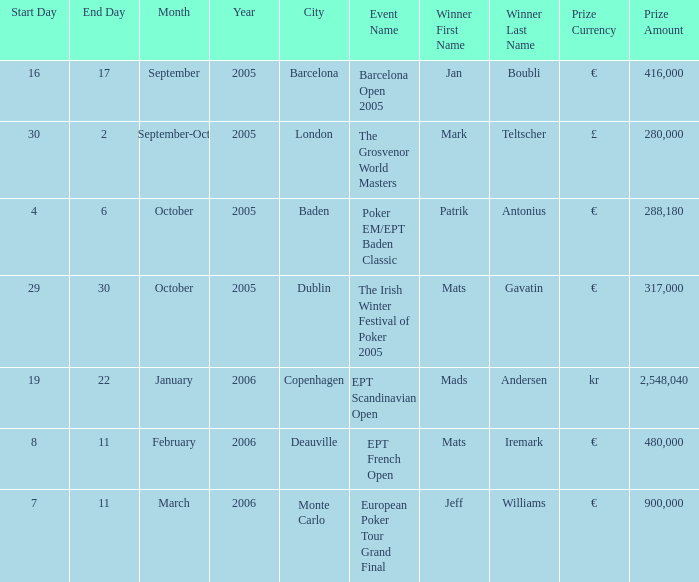Parse the table in full. {'header': ['Start Day', 'End Day', 'Month', 'Year', 'City', 'Event Name', 'Winner First Name', 'Winner Last Name', 'Prize Currency', 'Prize Amount'], 'rows': [['16', '17', 'September', '2005', 'Barcelona', 'Barcelona Open 2005', 'Jan', 'Boubli', '€', '416,000'], ['30', '2', 'September-Oct', '2005', 'London', 'The Grosvenor World Masters', 'Mark', 'Teltscher', '£', '280,000'], ['4', '6', 'October', '2005', 'Baden', 'Poker EM/EPT Baden Classic', 'Patrik', 'Antonius', '€', '288,180'], ['29', '30', 'October', '2005', 'Dublin', 'The Irish Winter Festival of Poker 2005', 'Mats', 'Gavatin', '€', '317,000'], ['19', '22', 'January', '2006', 'Copenhagen', 'EPT Scandinavian Open', 'Mads', 'Andersen', 'kr', '2,548,040'], ['8', '11', 'February', '2006', 'Deauville', 'EPT French Open', 'Mats', 'Iremark', '€', '480,000'], ['7', '11', 'March', '2006', 'Monte Carlo', 'European Poker Tour Grand Final', 'Jeff', 'Williams', '€', '900,000']]} In which city did patrik antonius win the event? Baden. 